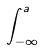<formula> <loc_0><loc_0><loc_500><loc_500>\int _ { - \infty } ^ { a }</formula> 